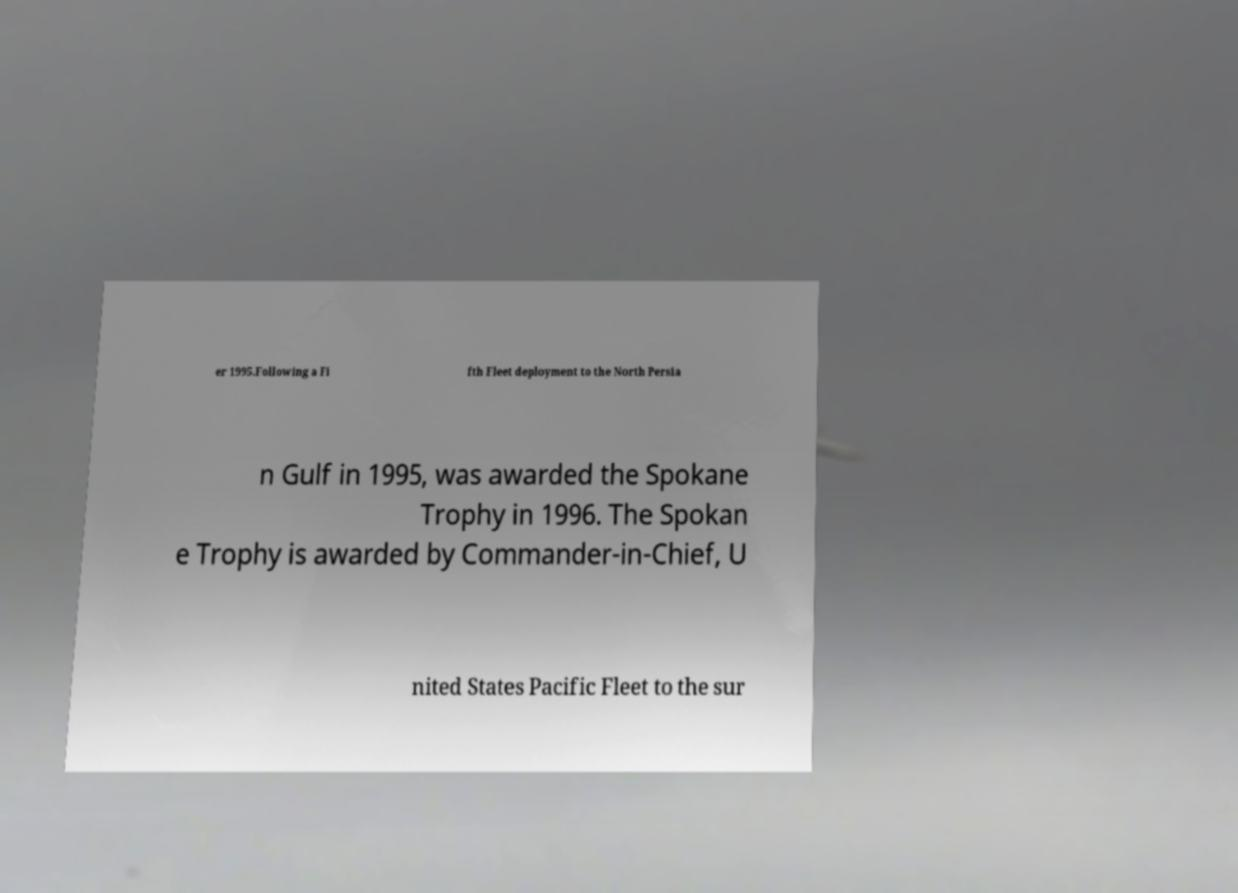For documentation purposes, I need the text within this image transcribed. Could you provide that? er 1995.Following a Fi fth Fleet deployment to the North Persia n Gulf in 1995, was awarded the Spokane Trophy in 1996. The Spokan e Trophy is awarded by Commander-in-Chief, U nited States Pacific Fleet to the sur 